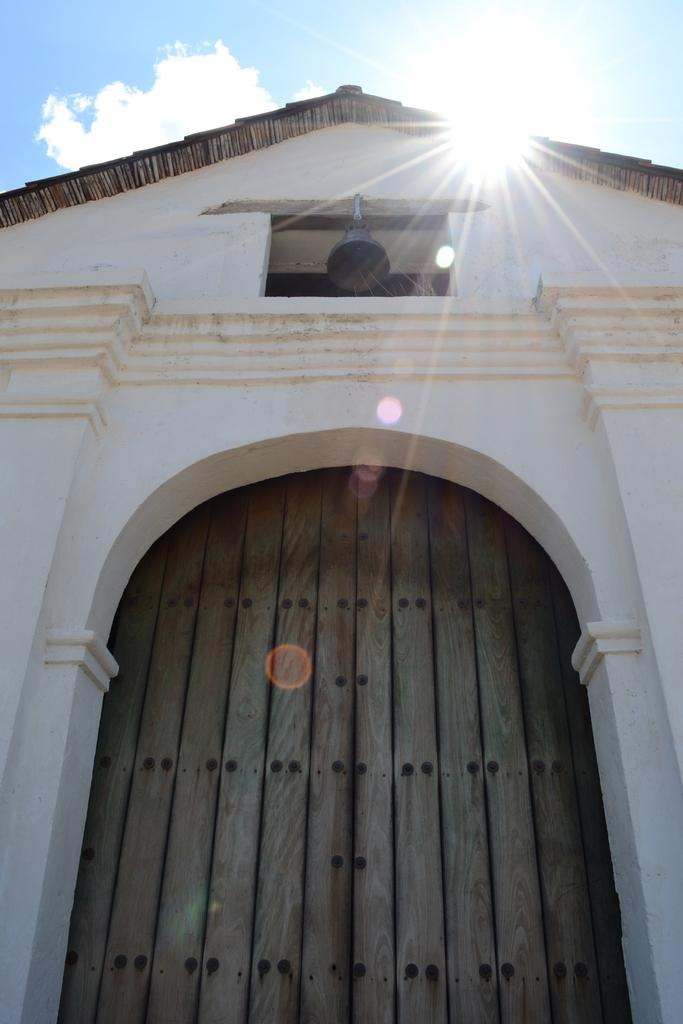What type of building is in the image? There is a parish building in the image. What is the material of the door on the building? The building has a wooden door. What is hanging on the building? The building has a bell. What is visible at the top of the image? The top of the image features a roof. What is the condition of the sky in the image? The sky is clear in the image. How many dimes can be seen on the roof of the building in the image? There are no dimes visible on the roof of the building in the image. What level of the building is the loss occurring on? There is no mention of a loss or any levels in the image. 